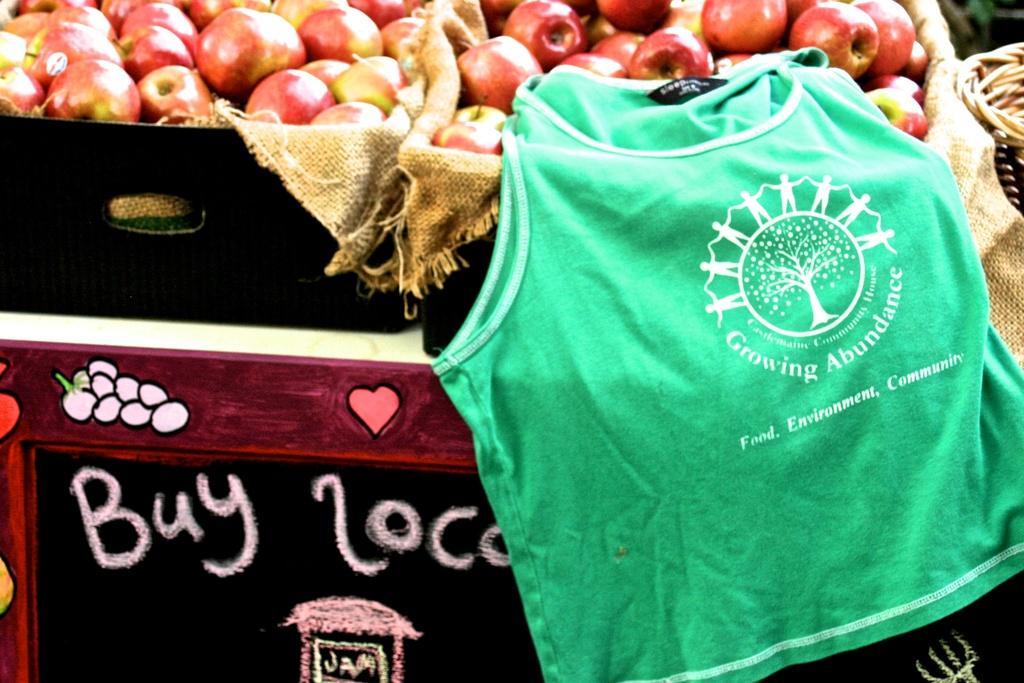How would you summarize this image in a sentence or two? In this picture we can see a fruit stall with basket of apples and a green t-shirt on it. 